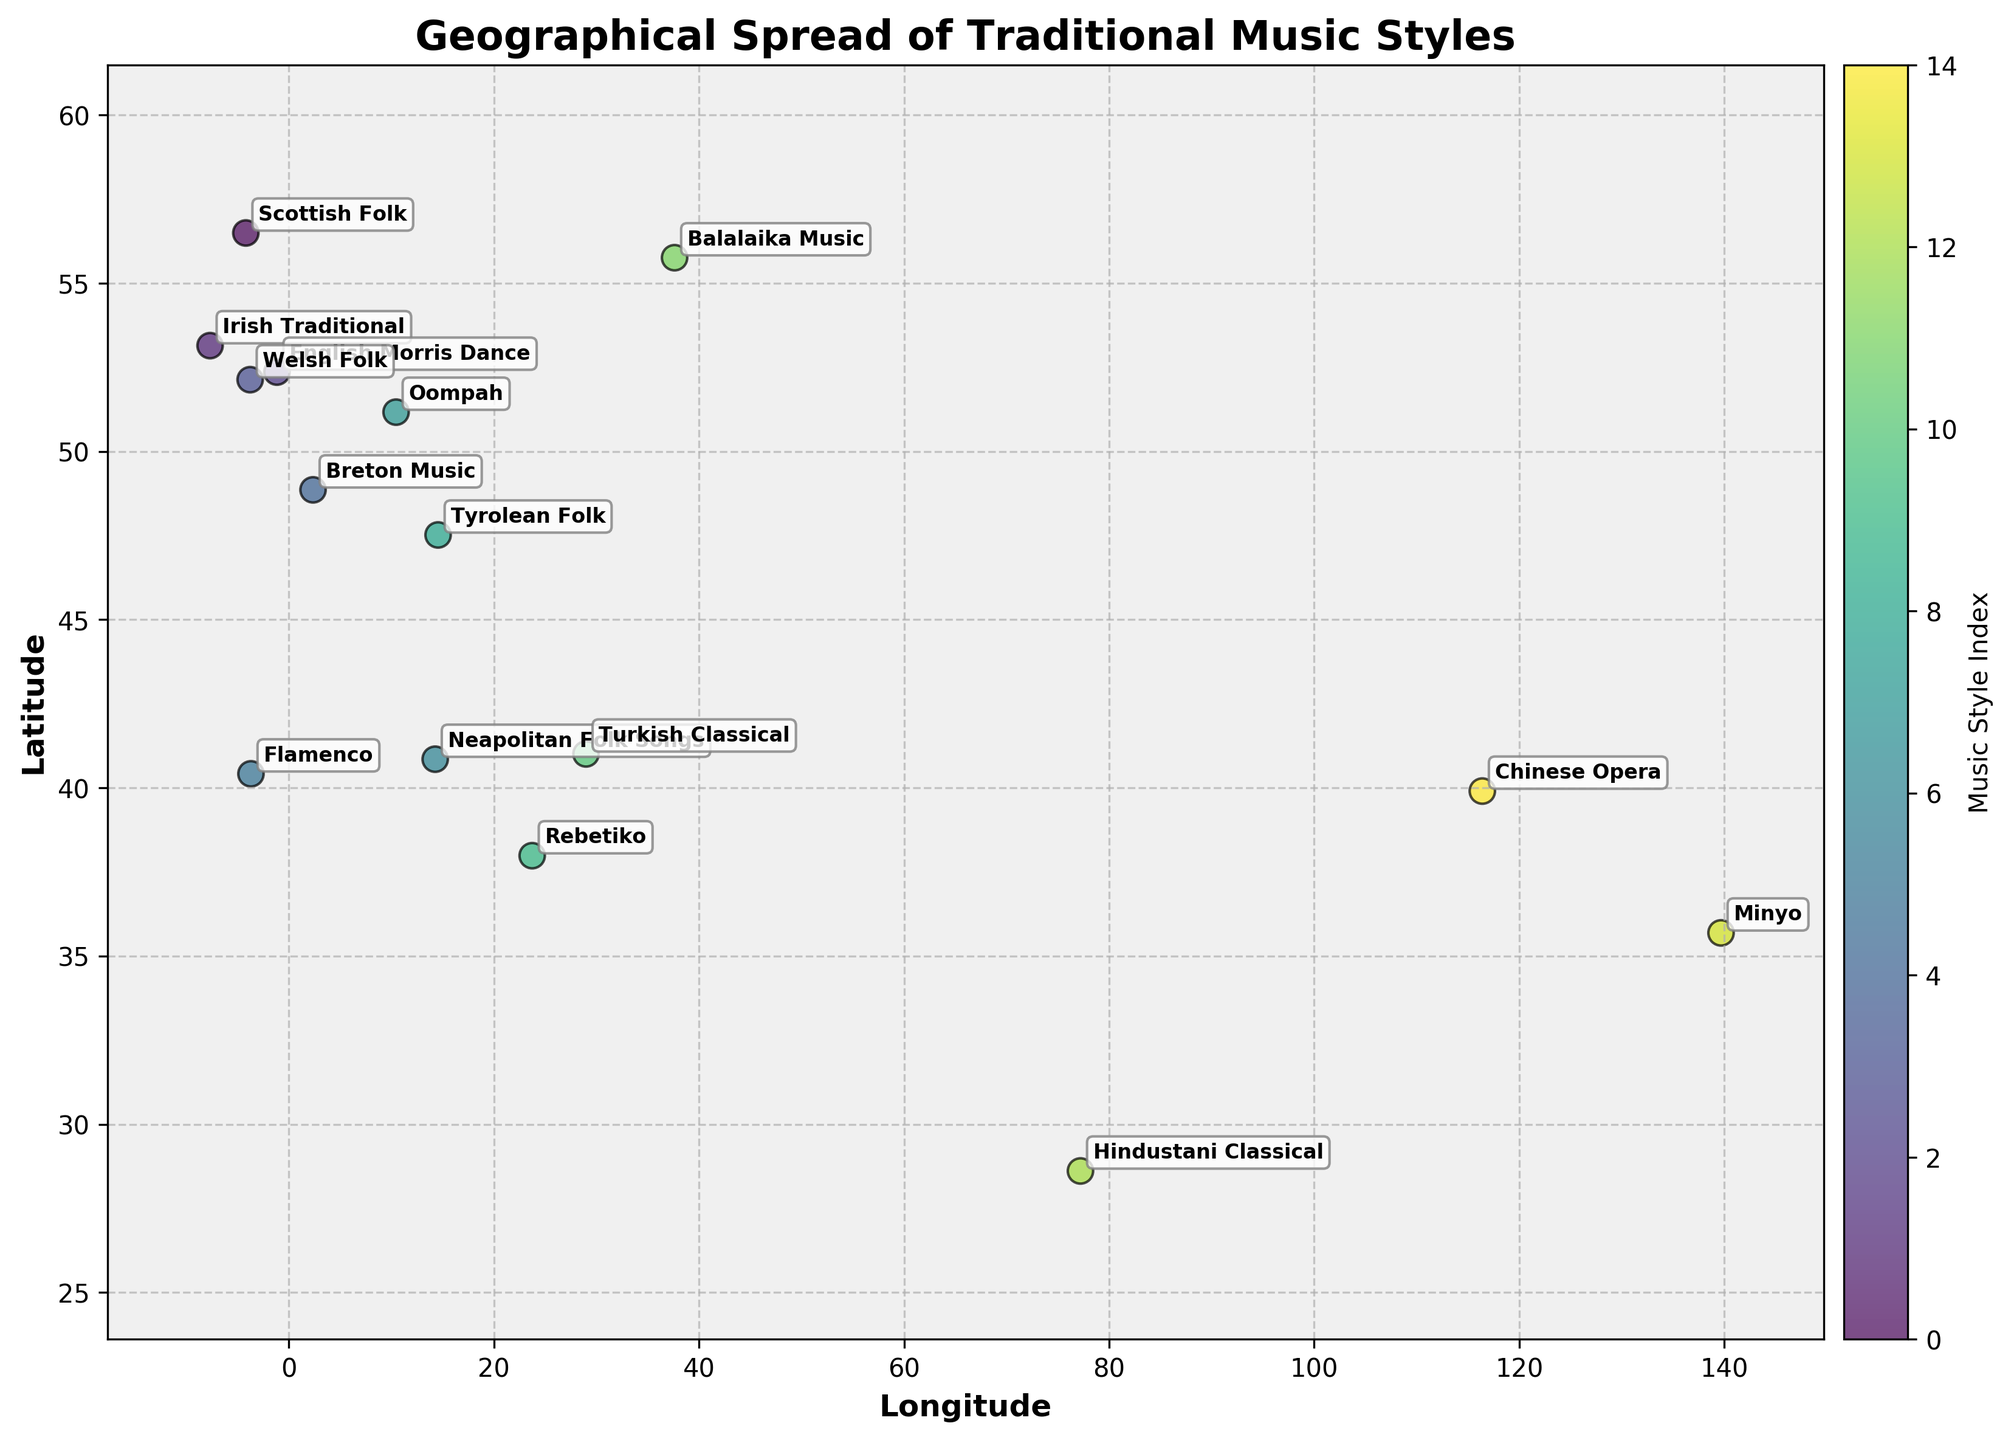What is the title of the plot? The title is usually located at the top of the plot. It provides a brief description of what the plot is about. In this case, look at the top center of the figure.
Answer: Geographical Spread of Traditional Music Styles How many data points are shown on the scatter plot? Each data point represents a different music style and is marked by a colored dot on the scatter plot. By counting these dots, you can determine the total number of data points.
Answer: 15 Which region is represented by the data point with the highest latitude? Locate the data point that is highest on the vertical axis (latitude) and check the corresponding region name annotated near it.
Answer: Scotland What's the longitude range covered by the scatter plot? The x-axis represents longitude, and the range can be observed by checking the minimum and maximum values on this axis. Note the values and calculate the range.
Answer: -4.2026 to 139.6917 Which two music styles are closest to each other geographically? Compare the data points' latitude and longitude annotations. The two that have the smallest distance between them are the closest geographically.
Answer: English Morris Dance and Welsh Folk Which region has a music style closest to the center of the plot? Identify the approximate center of the plot using the axis scales, then find the data point nearest to this center by its coordinates.
Answer: Italy (Neapolitan Folk Songs) What is the latitude of Indian music style? Locate the data point annotated with "Hindustani Classical" and read the latitude value from its position on the vertical axis.
Answer: 28.6139 Compare the latitude of Scottish Folk and Balalaika Music. Which one is higher? Locate the data points for Scottish Folk and Balalaika Music on the map and compare their corresponding latitude values.
Answer: Scottish Folk Which music styles are found in regions with a longitude above 100? Identify data points with longitudes greater than 100 on the x-axis, then list the music styles annotated near these points.
Answer: Minyo, Chinese Opera Is the longitude of Turkish Classical music positive or negative? Find the data point labeled "Turkish Classical" and check its position on the x-axis to determine if it lies to the right (positive) or left (negative) of the origin.
Answer: Positive 